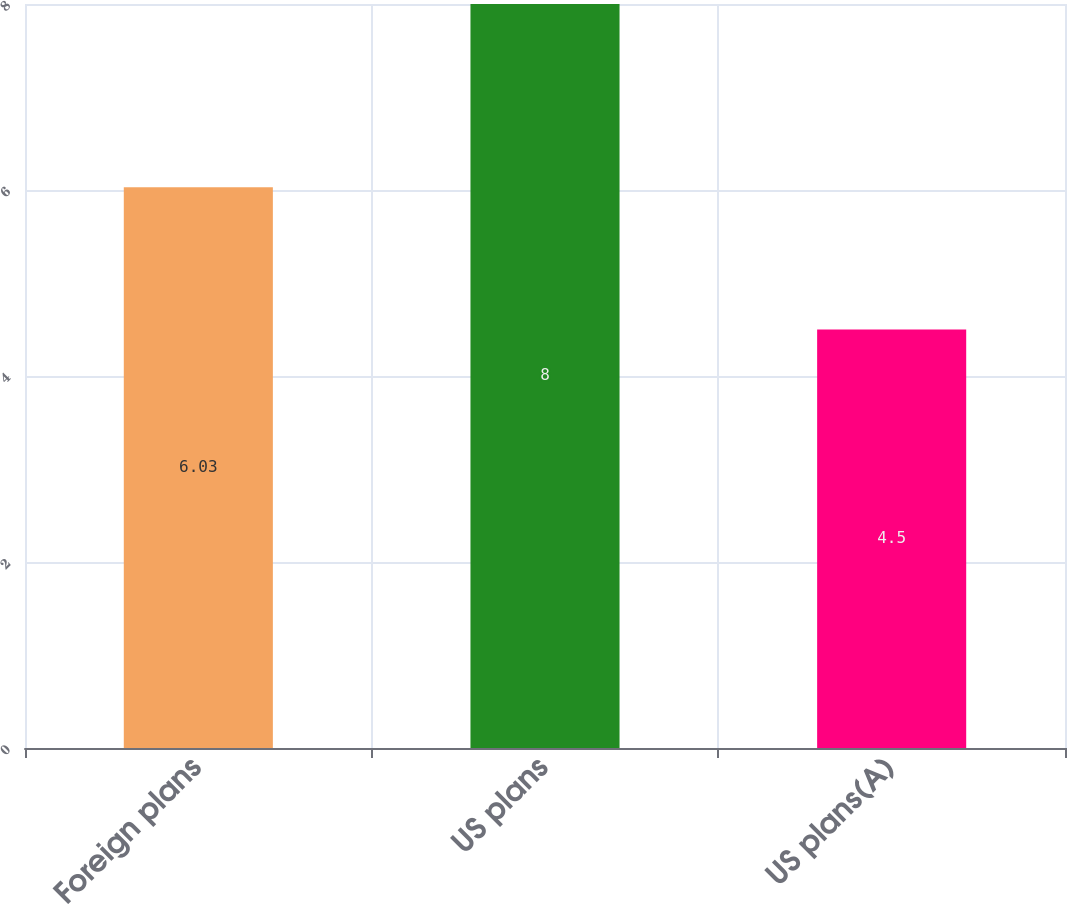Convert chart to OTSL. <chart><loc_0><loc_0><loc_500><loc_500><bar_chart><fcel>Foreign plans<fcel>US plans<fcel>US plans(A)<nl><fcel>6.03<fcel>8<fcel>4.5<nl></chart> 